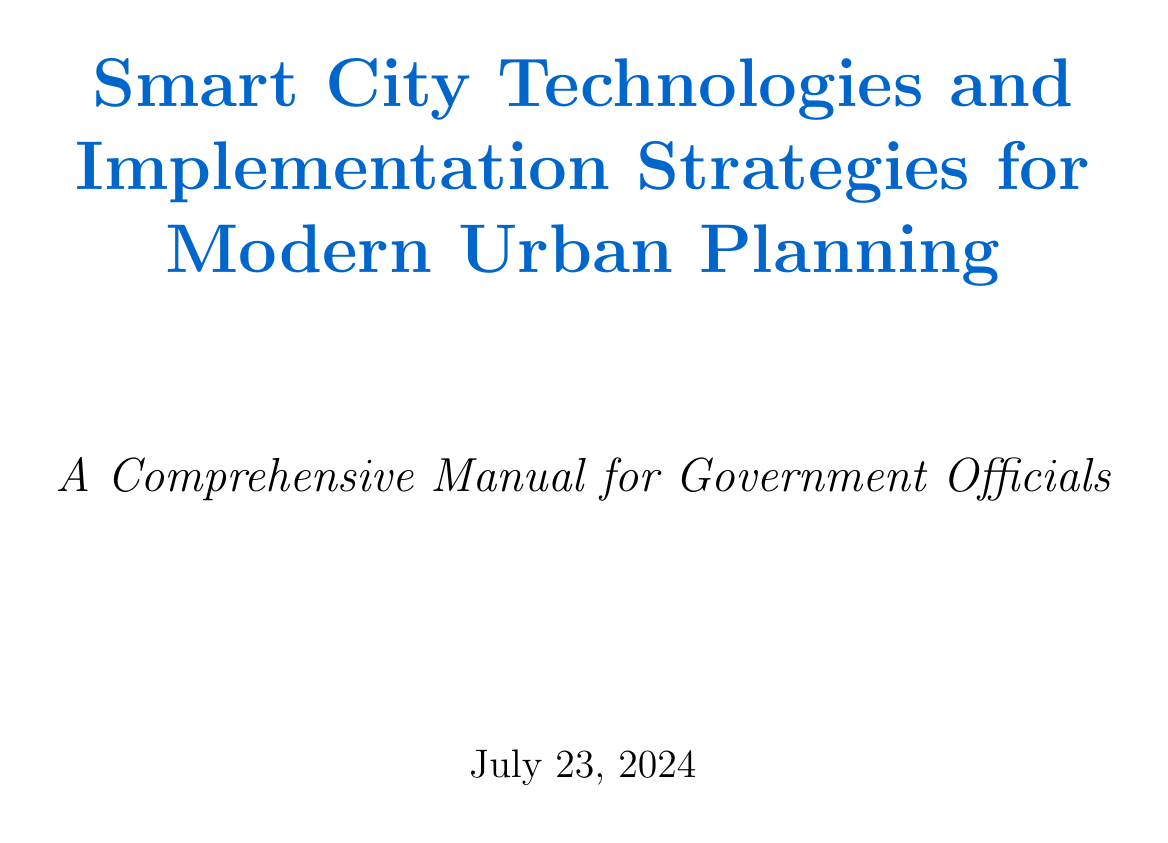What is the title of the manual? The title of the manual is stated in the document as "Smart City Technologies and Implementation Strategies for Modern Urban Planning."
Answer: Smart City Technologies and Implementation Strategies for Modern Urban Planning What is a key feature of Singapore's Smart Nation Initiative? The document lists key features of various case studies, including "National Digital Identity system" for Singapore.
Answer: National Digital Identity system Which technology is used for multimodal transportation information? The section on Smart Transportation Systems mentions "TransitScreen" as an example for multimodal transportation information.
Answer: TransitScreen What is one strategy for citizen engagement mentioned? In the Implementation Strategies section, "Citizen engagement and participation strategies" is one of the listed strategies.
Answer: Citizen engagement and participation strategies How many chapters are in the manual? The document structure outlines a total of seven chapters, which can be counted from the list.
Answer: Seven Who published the Smart Cities Council? The resources section lists the "Smart Cities Council" with its website but does not specify a publisher.
Answer: Not specified What does "Digital Twin" refer to? The glossary explains that a "Digital Twin" is a virtual representation of a physical object or system.
Answer: A virtual representation of a physical object or system What is the purpose of this manual? The purpose is expressed in the introduction as providing comprehensive guidance on smart city technologies and implementation strategies.
Answer: Comprehensive guidance on smart city technologies and implementation strategies 